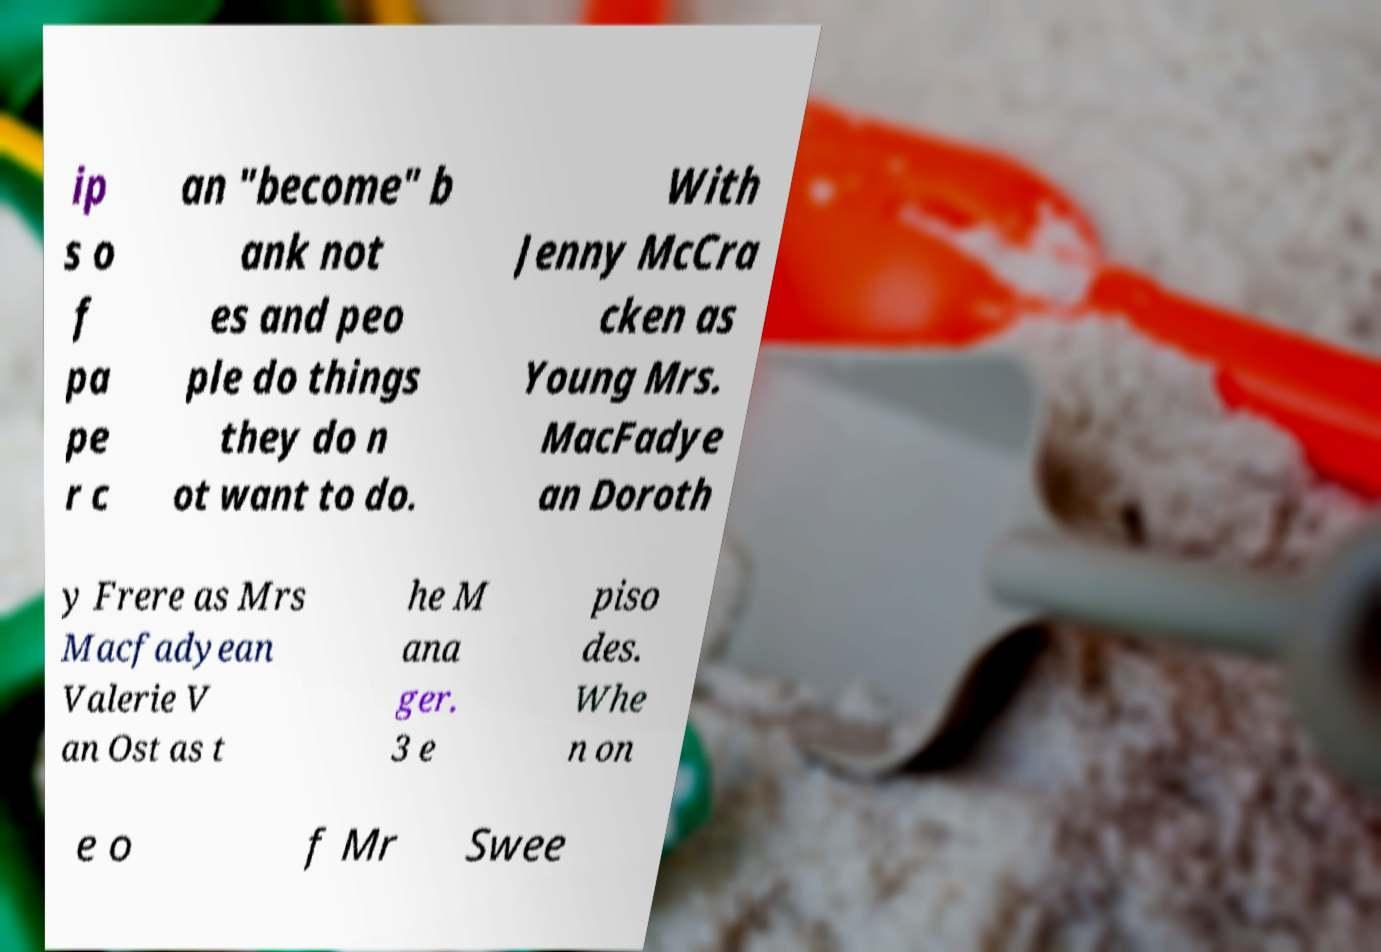For documentation purposes, I need the text within this image transcribed. Could you provide that? ip s o f pa pe r c an "become" b ank not es and peo ple do things they do n ot want to do. With Jenny McCra cken as Young Mrs. MacFadye an Doroth y Frere as Mrs Macfadyean Valerie V an Ost as t he M ana ger. 3 e piso des. Whe n on e o f Mr Swee 